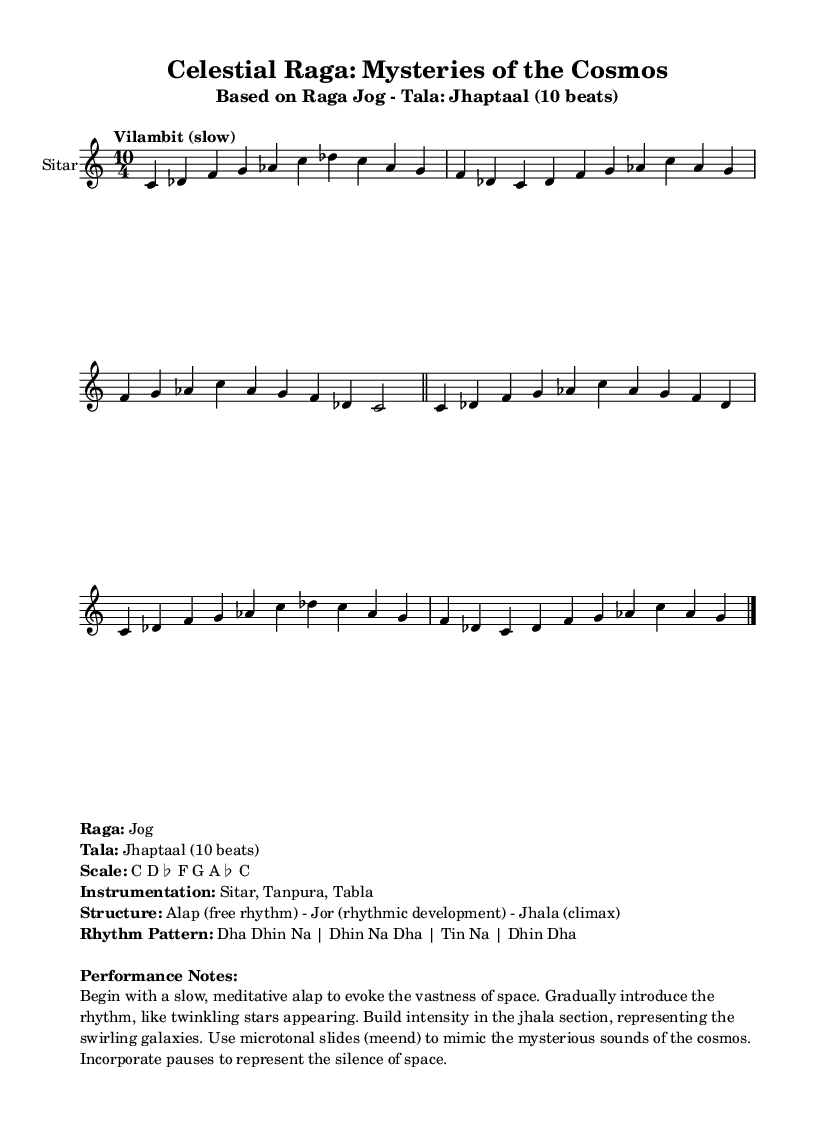What is the time signature of this music? The time signature is indicated at the beginning of the score as 10/4, meaning there are 10 beats in each measure, with a quarter note receiving one beat.
Answer: 10/4 What is the tempo marking for the piece? The tempo marking is found at the start and is labeled "Vilambit (slow)," indicating a slow tempo for the performance of the raga.
Answer: Vilambit (slow) What is the scale used in this raga? The scale is listed in the markup section and includes the notes C, D-flat, F, G, A-flat, and C, which collectively form its unique structure.
Answer: C D-flat F G A-flat C How many sections are there in the raga's structure? The structure of the raga is described as having three distinct sections: Alap, Jor, and Jhala, indicating three parts to the performance.
Answer: Three In what way does the performance mimic the cosmos? The performance notes suggest techniques like a slow, meditative beginning to evoke space, rhythm's gradual introduction to represent stars, and microtonal slides to capture cosmic sounds, showcasing a deep connection with space.
Answer: Evokes space, stars, cosmic sounds 